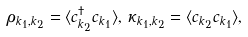<formula> <loc_0><loc_0><loc_500><loc_500>\rho _ { k _ { 1 } , k _ { 2 } } = \langle c _ { k _ { 2 } } ^ { \dagger } c _ { k _ { 1 } } \rangle , \, \kappa _ { k _ { 1 } , k _ { 2 } } = \langle c _ { k _ { 2 } } c _ { k _ { 1 } } \rangle ,</formula> 